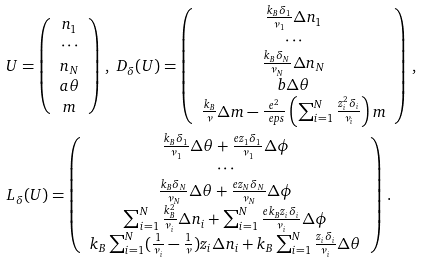<formula> <loc_0><loc_0><loc_500><loc_500>& U = \left ( \begin{array} { c } n _ { 1 } \\ \cdots \\ n _ { N } \\ a \theta \\ m \end{array} \right ) \, , \ D _ { \delta } ( U ) = \left ( \begin{array} { c } \frac { k _ { B } \delta _ { 1 } } { \nu _ { 1 } } \Delta n _ { 1 } \\ \cdots \\ \frac { k _ { B } \delta _ { N } } { \nu _ { N } } \Delta n _ { N } \\ b \Delta \theta \\ \frac { k _ { B } } { \nu } \Delta m - \frac { e ^ { 2 } } { \ e p s } \left ( \sum _ { i = 1 } ^ { N } \frac { z _ { i } ^ { 2 } \delta _ { i } } { \nu _ { i } } \right ) m \end{array} \right ) \, , \\ & L _ { \delta } ( U ) = \left ( \begin{array} { c } \frac { k _ { B } \delta _ { 1 } } { \nu _ { 1 } } \Delta \theta + \frac { e z _ { 1 } \delta _ { 1 } } { \nu _ { 1 } } \Delta \phi \\ \cdots \\ \frac { k _ { B } \delta _ { N } } { \nu _ { N } } \Delta \theta + \frac { e z _ { N } \delta _ { N } } { \nu _ { N } } \Delta \phi \\ \sum _ { i = 1 } ^ { N } \frac { k _ { B } ^ { 2 } } { \nu _ { i } } \Delta n _ { i } + \sum _ { i = 1 } ^ { N } \frac { e k _ { B } z _ { i } \delta _ { i } } { \nu _ { i } } \Delta \phi \\ k _ { B } \sum _ { i = 1 } ^ { N } ( \frac { 1 } { \nu _ { i } } - \frac { 1 } { \nu } ) z _ { i } \Delta n _ { i } + k _ { B } \sum _ { i = 1 } ^ { N } \frac { z _ { i } \delta _ { i } } { \nu _ { i } } \Delta \theta \end{array} \right ) \, .</formula> 